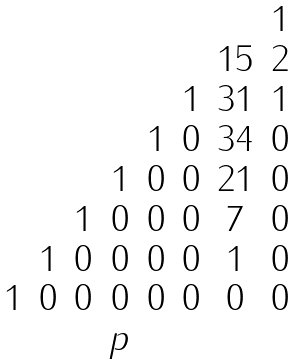<formula> <loc_0><loc_0><loc_500><loc_500>\begin{matrix} & & & & & & & 1 \\ & & & & & & 1 5 & 2 \\ & & & & & 1 & 3 1 & 1 \\ & & & & 1 & 0 & 3 4 & 0 \\ & & & 1 & 0 & 0 & 2 1 & 0 \\ & & 1 & 0 & 0 & 0 & 7 & 0 \\ & 1 & 0 & 0 & 0 & 0 & 1 & 0 \\ 1 & 0 & 0 & 0 & 0 & 0 & 0 & 0 \\ & & & p & & \end{matrix}</formula> 